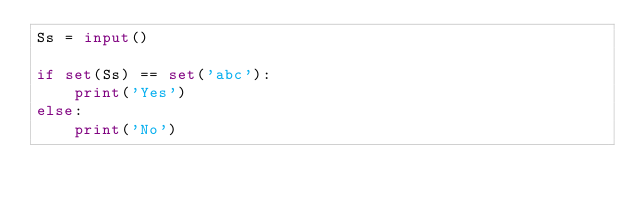<code> <loc_0><loc_0><loc_500><loc_500><_Python_>Ss = input()

if set(Ss) == set('abc'):
    print('Yes')
else:
    print('No')
</code> 